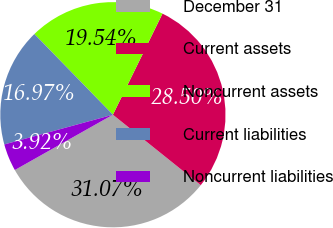<chart> <loc_0><loc_0><loc_500><loc_500><pie_chart><fcel>December 31<fcel>Current assets<fcel>Noncurrent assets<fcel>Current liabilities<fcel>Noncurrent liabilities<nl><fcel>31.07%<fcel>28.5%<fcel>19.54%<fcel>16.97%<fcel>3.92%<nl></chart> 